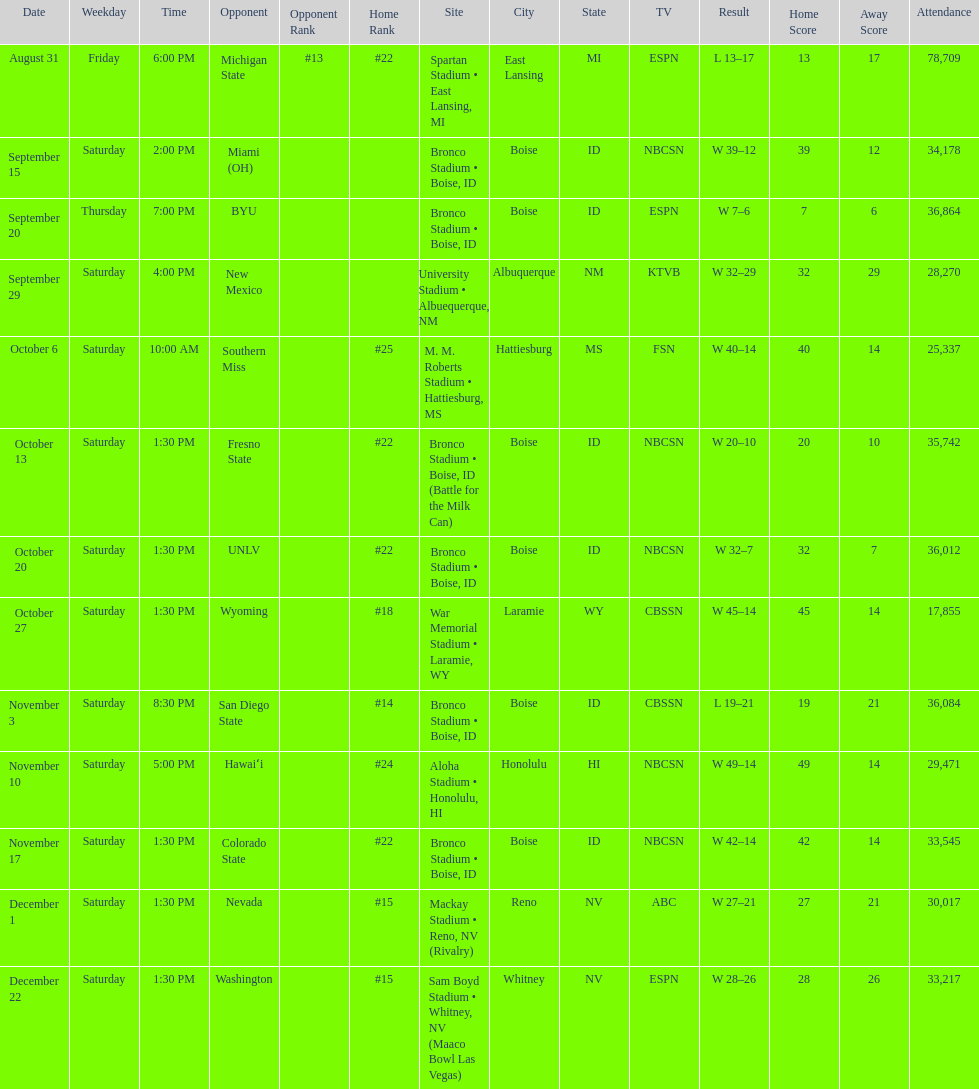What is the total number of games played at bronco stadium? 6. 